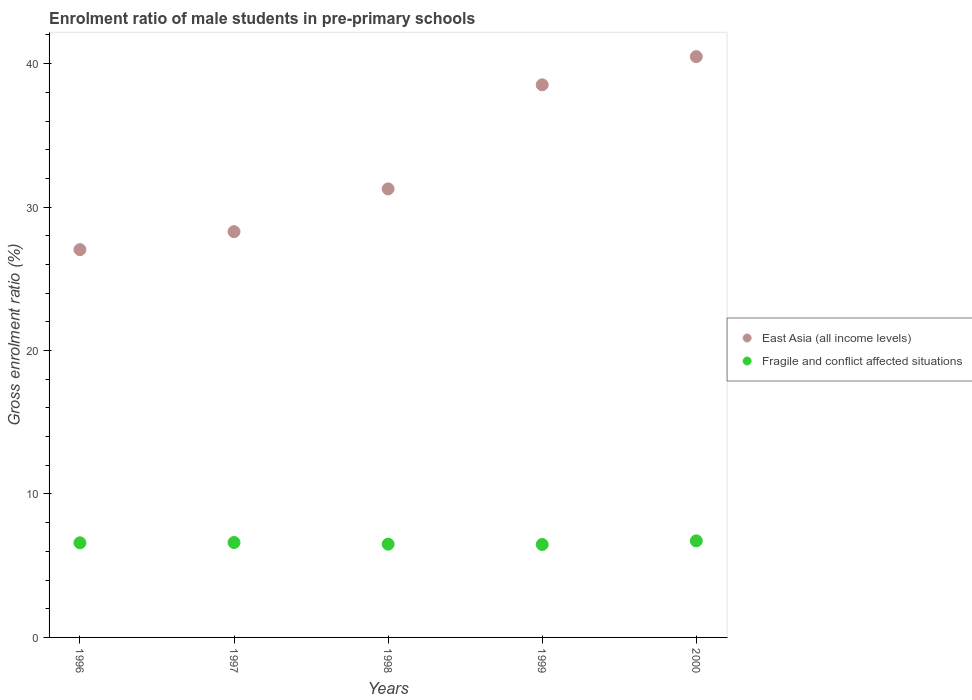How many different coloured dotlines are there?
Offer a terse response. 2. What is the enrolment ratio of male students in pre-primary schools in East Asia (all income levels) in 1996?
Ensure brevity in your answer.  27.03. Across all years, what is the maximum enrolment ratio of male students in pre-primary schools in Fragile and conflict affected situations?
Make the answer very short. 6.73. Across all years, what is the minimum enrolment ratio of male students in pre-primary schools in East Asia (all income levels)?
Make the answer very short. 27.03. What is the total enrolment ratio of male students in pre-primary schools in East Asia (all income levels) in the graph?
Offer a very short reply. 165.6. What is the difference between the enrolment ratio of male students in pre-primary schools in East Asia (all income levels) in 1999 and that in 2000?
Offer a very short reply. -1.96. What is the difference between the enrolment ratio of male students in pre-primary schools in East Asia (all income levels) in 1998 and the enrolment ratio of male students in pre-primary schools in Fragile and conflict affected situations in 1999?
Your response must be concise. 24.79. What is the average enrolment ratio of male students in pre-primary schools in Fragile and conflict affected situations per year?
Ensure brevity in your answer.  6.59. In the year 1998, what is the difference between the enrolment ratio of male students in pre-primary schools in Fragile and conflict affected situations and enrolment ratio of male students in pre-primary schools in East Asia (all income levels)?
Your answer should be very brief. -24.76. In how many years, is the enrolment ratio of male students in pre-primary schools in East Asia (all income levels) greater than 14 %?
Offer a very short reply. 5. What is the ratio of the enrolment ratio of male students in pre-primary schools in East Asia (all income levels) in 1996 to that in 1998?
Offer a very short reply. 0.86. Is the difference between the enrolment ratio of male students in pre-primary schools in Fragile and conflict affected situations in 1999 and 2000 greater than the difference between the enrolment ratio of male students in pre-primary schools in East Asia (all income levels) in 1999 and 2000?
Ensure brevity in your answer.  Yes. What is the difference between the highest and the second highest enrolment ratio of male students in pre-primary schools in Fragile and conflict affected situations?
Offer a terse response. 0.12. What is the difference between the highest and the lowest enrolment ratio of male students in pre-primary schools in Fragile and conflict affected situations?
Your answer should be very brief. 0.25. In how many years, is the enrolment ratio of male students in pre-primary schools in East Asia (all income levels) greater than the average enrolment ratio of male students in pre-primary schools in East Asia (all income levels) taken over all years?
Your answer should be very brief. 2. Does the enrolment ratio of male students in pre-primary schools in Fragile and conflict affected situations monotonically increase over the years?
Your answer should be very brief. No. Is the enrolment ratio of male students in pre-primary schools in Fragile and conflict affected situations strictly less than the enrolment ratio of male students in pre-primary schools in East Asia (all income levels) over the years?
Provide a short and direct response. Yes. Are the values on the major ticks of Y-axis written in scientific E-notation?
Your response must be concise. No. What is the title of the graph?
Give a very brief answer. Enrolment ratio of male students in pre-primary schools. Does "Upper middle income" appear as one of the legend labels in the graph?
Offer a very short reply. No. What is the label or title of the X-axis?
Make the answer very short. Years. What is the Gross enrolment ratio (%) of East Asia (all income levels) in 1996?
Make the answer very short. 27.03. What is the Gross enrolment ratio (%) of Fragile and conflict affected situations in 1996?
Your response must be concise. 6.6. What is the Gross enrolment ratio (%) in East Asia (all income levels) in 1997?
Offer a very short reply. 28.29. What is the Gross enrolment ratio (%) of Fragile and conflict affected situations in 1997?
Offer a terse response. 6.62. What is the Gross enrolment ratio (%) of East Asia (all income levels) in 1998?
Provide a succinct answer. 31.27. What is the Gross enrolment ratio (%) in Fragile and conflict affected situations in 1998?
Make the answer very short. 6.5. What is the Gross enrolment ratio (%) of East Asia (all income levels) in 1999?
Ensure brevity in your answer.  38.52. What is the Gross enrolment ratio (%) in Fragile and conflict affected situations in 1999?
Make the answer very short. 6.48. What is the Gross enrolment ratio (%) in East Asia (all income levels) in 2000?
Offer a terse response. 40.49. What is the Gross enrolment ratio (%) in Fragile and conflict affected situations in 2000?
Offer a very short reply. 6.73. Across all years, what is the maximum Gross enrolment ratio (%) of East Asia (all income levels)?
Your response must be concise. 40.49. Across all years, what is the maximum Gross enrolment ratio (%) of Fragile and conflict affected situations?
Your answer should be compact. 6.73. Across all years, what is the minimum Gross enrolment ratio (%) in East Asia (all income levels)?
Your response must be concise. 27.03. Across all years, what is the minimum Gross enrolment ratio (%) in Fragile and conflict affected situations?
Ensure brevity in your answer.  6.48. What is the total Gross enrolment ratio (%) in East Asia (all income levels) in the graph?
Make the answer very short. 165.6. What is the total Gross enrolment ratio (%) of Fragile and conflict affected situations in the graph?
Offer a terse response. 32.93. What is the difference between the Gross enrolment ratio (%) in East Asia (all income levels) in 1996 and that in 1997?
Provide a succinct answer. -1.25. What is the difference between the Gross enrolment ratio (%) of Fragile and conflict affected situations in 1996 and that in 1997?
Keep it short and to the point. -0.02. What is the difference between the Gross enrolment ratio (%) of East Asia (all income levels) in 1996 and that in 1998?
Offer a very short reply. -4.23. What is the difference between the Gross enrolment ratio (%) of Fragile and conflict affected situations in 1996 and that in 1998?
Offer a very short reply. 0.09. What is the difference between the Gross enrolment ratio (%) of East Asia (all income levels) in 1996 and that in 1999?
Make the answer very short. -11.49. What is the difference between the Gross enrolment ratio (%) in Fragile and conflict affected situations in 1996 and that in 1999?
Your answer should be very brief. 0.12. What is the difference between the Gross enrolment ratio (%) of East Asia (all income levels) in 1996 and that in 2000?
Keep it short and to the point. -13.45. What is the difference between the Gross enrolment ratio (%) in Fragile and conflict affected situations in 1996 and that in 2000?
Your answer should be compact. -0.14. What is the difference between the Gross enrolment ratio (%) in East Asia (all income levels) in 1997 and that in 1998?
Your answer should be very brief. -2.98. What is the difference between the Gross enrolment ratio (%) in Fragile and conflict affected situations in 1997 and that in 1998?
Provide a succinct answer. 0.12. What is the difference between the Gross enrolment ratio (%) of East Asia (all income levels) in 1997 and that in 1999?
Ensure brevity in your answer.  -10.24. What is the difference between the Gross enrolment ratio (%) in Fragile and conflict affected situations in 1997 and that in 1999?
Provide a short and direct response. 0.14. What is the difference between the Gross enrolment ratio (%) of East Asia (all income levels) in 1997 and that in 2000?
Keep it short and to the point. -12.2. What is the difference between the Gross enrolment ratio (%) of Fragile and conflict affected situations in 1997 and that in 2000?
Keep it short and to the point. -0.12. What is the difference between the Gross enrolment ratio (%) of East Asia (all income levels) in 1998 and that in 1999?
Provide a short and direct response. -7.26. What is the difference between the Gross enrolment ratio (%) of Fragile and conflict affected situations in 1998 and that in 1999?
Offer a very short reply. 0.02. What is the difference between the Gross enrolment ratio (%) of East Asia (all income levels) in 1998 and that in 2000?
Your answer should be very brief. -9.22. What is the difference between the Gross enrolment ratio (%) in Fragile and conflict affected situations in 1998 and that in 2000?
Make the answer very short. -0.23. What is the difference between the Gross enrolment ratio (%) in East Asia (all income levels) in 1999 and that in 2000?
Ensure brevity in your answer.  -1.96. What is the difference between the Gross enrolment ratio (%) of Fragile and conflict affected situations in 1999 and that in 2000?
Give a very brief answer. -0.25. What is the difference between the Gross enrolment ratio (%) of East Asia (all income levels) in 1996 and the Gross enrolment ratio (%) of Fragile and conflict affected situations in 1997?
Make the answer very short. 20.42. What is the difference between the Gross enrolment ratio (%) in East Asia (all income levels) in 1996 and the Gross enrolment ratio (%) in Fragile and conflict affected situations in 1998?
Make the answer very short. 20.53. What is the difference between the Gross enrolment ratio (%) of East Asia (all income levels) in 1996 and the Gross enrolment ratio (%) of Fragile and conflict affected situations in 1999?
Keep it short and to the point. 20.55. What is the difference between the Gross enrolment ratio (%) in East Asia (all income levels) in 1996 and the Gross enrolment ratio (%) in Fragile and conflict affected situations in 2000?
Provide a short and direct response. 20.3. What is the difference between the Gross enrolment ratio (%) in East Asia (all income levels) in 1997 and the Gross enrolment ratio (%) in Fragile and conflict affected situations in 1998?
Your response must be concise. 21.78. What is the difference between the Gross enrolment ratio (%) in East Asia (all income levels) in 1997 and the Gross enrolment ratio (%) in Fragile and conflict affected situations in 1999?
Offer a terse response. 21.81. What is the difference between the Gross enrolment ratio (%) in East Asia (all income levels) in 1997 and the Gross enrolment ratio (%) in Fragile and conflict affected situations in 2000?
Offer a very short reply. 21.55. What is the difference between the Gross enrolment ratio (%) in East Asia (all income levels) in 1998 and the Gross enrolment ratio (%) in Fragile and conflict affected situations in 1999?
Give a very brief answer. 24.79. What is the difference between the Gross enrolment ratio (%) in East Asia (all income levels) in 1998 and the Gross enrolment ratio (%) in Fragile and conflict affected situations in 2000?
Your response must be concise. 24.53. What is the difference between the Gross enrolment ratio (%) in East Asia (all income levels) in 1999 and the Gross enrolment ratio (%) in Fragile and conflict affected situations in 2000?
Offer a terse response. 31.79. What is the average Gross enrolment ratio (%) of East Asia (all income levels) per year?
Your answer should be compact. 33.12. What is the average Gross enrolment ratio (%) in Fragile and conflict affected situations per year?
Your response must be concise. 6.59. In the year 1996, what is the difference between the Gross enrolment ratio (%) in East Asia (all income levels) and Gross enrolment ratio (%) in Fragile and conflict affected situations?
Keep it short and to the point. 20.44. In the year 1997, what is the difference between the Gross enrolment ratio (%) in East Asia (all income levels) and Gross enrolment ratio (%) in Fragile and conflict affected situations?
Your answer should be compact. 21.67. In the year 1998, what is the difference between the Gross enrolment ratio (%) in East Asia (all income levels) and Gross enrolment ratio (%) in Fragile and conflict affected situations?
Ensure brevity in your answer.  24.76. In the year 1999, what is the difference between the Gross enrolment ratio (%) of East Asia (all income levels) and Gross enrolment ratio (%) of Fragile and conflict affected situations?
Give a very brief answer. 32.04. In the year 2000, what is the difference between the Gross enrolment ratio (%) in East Asia (all income levels) and Gross enrolment ratio (%) in Fragile and conflict affected situations?
Make the answer very short. 33.76. What is the ratio of the Gross enrolment ratio (%) of East Asia (all income levels) in 1996 to that in 1997?
Your answer should be very brief. 0.96. What is the ratio of the Gross enrolment ratio (%) in East Asia (all income levels) in 1996 to that in 1998?
Keep it short and to the point. 0.86. What is the ratio of the Gross enrolment ratio (%) of Fragile and conflict affected situations in 1996 to that in 1998?
Your answer should be very brief. 1.01. What is the ratio of the Gross enrolment ratio (%) of East Asia (all income levels) in 1996 to that in 1999?
Provide a short and direct response. 0.7. What is the ratio of the Gross enrolment ratio (%) in Fragile and conflict affected situations in 1996 to that in 1999?
Your response must be concise. 1.02. What is the ratio of the Gross enrolment ratio (%) of East Asia (all income levels) in 1996 to that in 2000?
Make the answer very short. 0.67. What is the ratio of the Gross enrolment ratio (%) of Fragile and conflict affected situations in 1996 to that in 2000?
Give a very brief answer. 0.98. What is the ratio of the Gross enrolment ratio (%) in East Asia (all income levels) in 1997 to that in 1998?
Give a very brief answer. 0.9. What is the ratio of the Gross enrolment ratio (%) of Fragile and conflict affected situations in 1997 to that in 1998?
Provide a short and direct response. 1.02. What is the ratio of the Gross enrolment ratio (%) in East Asia (all income levels) in 1997 to that in 1999?
Offer a terse response. 0.73. What is the ratio of the Gross enrolment ratio (%) in Fragile and conflict affected situations in 1997 to that in 1999?
Your response must be concise. 1.02. What is the ratio of the Gross enrolment ratio (%) in East Asia (all income levels) in 1997 to that in 2000?
Offer a very short reply. 0.7. What is the ratio of the Gross enrolment ratio (%) in Fragile and conflict affected situations in 1997 to that in 2000?
Your response must be concise. 0.98. What is the ratio of the Gross enrolment ratio (%) in East Asia (all income levels) in 1998 to that in 1999?
Make the answer very short. 0.81. What is the ratio of the Gross enrolment ratio (%) in East Asia (all income levels) in 1998 to that in 2000?
Offer a terse response. 0.77. What is the ratio of the Gross enrolment ratio (%) of Fragile and conflict affected situations in 1998 to that in 2000?
Provide a short and direct response. 0.97. What is the ratio of the Gross enrolment ratio (%) in East Asia (all income levels) in 1999 to that in 2000?
Provide a succinct answer. 0.95. What is the ratio of the Gross enrolment ratio (%) in Fragile and conflict affected situations in 1999 to that in 2000?
Offer a very short reply. 0.96. What is the difference between the highest and the second highest Gross enrolment ratio (%) of East Asia (all income levels)?
Your answer should be very brief. 1.96. What is the difference between the highest and the second highest Gross enrolment ratio (%) of Fragile and conflict affected situations?
Your response must be concise. 0.12. What is the difference between the highest and the lowest Gross enrolment ratio (%) of East Asia (all income levels)?
Ensure brevity in your answer.  13.45. What is the difference between the highest and the lowest Gross enrolment ratio (%) of Fragile and conflict affected situations?
Give a very brief answer. 0.25. 